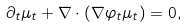<formula> <loc_0><loc_0><loc_500><loc_500>\partial _ { t } \mu _ { t } + \nabla \cdot ( \nabla \varphi _ { t } \mu _ { t } ) = 0 ,</formula> 